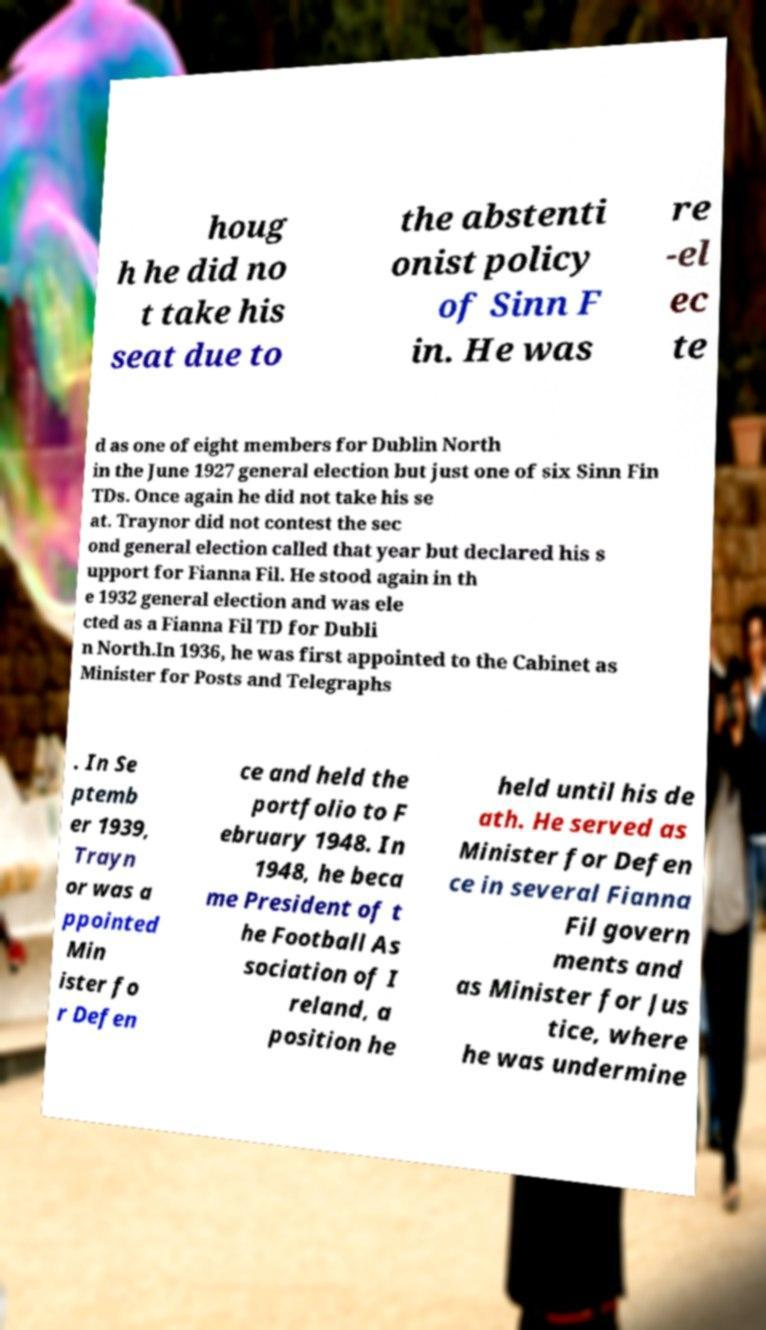What messages or text are displayed in this image? I need them in a readable, typed format. houg h he did no t take his seat due to the abstenti onist policy of Sinn F in. He was re -el ec te d as one of eight members for Dublin North in the June 1927 general election but just one of six Sinn Fin TDs. Once again he did not take his se at. Traynor did not contest the sec ond general election called that year but declared his s upport for Fianna Fil. He stood again in th e 1932 general election and was ele cted as a Fianna Fil TD for Dubli n North.In 1936, he was first appointed to the Cabinet as Minister for Posts and Telegraphs . In Se ptemb er 1939, Trayn or was a ppointed Min ister fo r Defen ce and held the portfolio to F ebruary 1948. In 1948, he beca me President of t he Football As sociation of I reland, a position he held until his de ath. He served as Minister for Defen ce in several Fianna Fil govern ments and as Minister for Jus tice, where he was undermine 